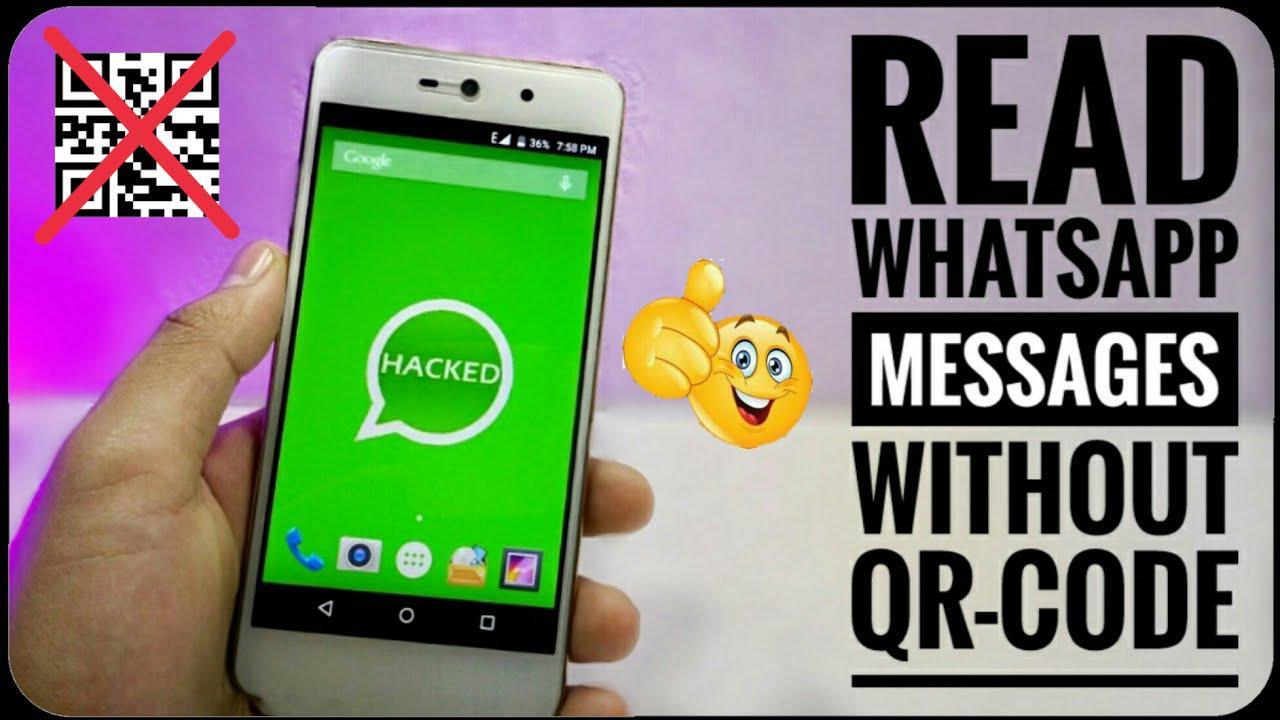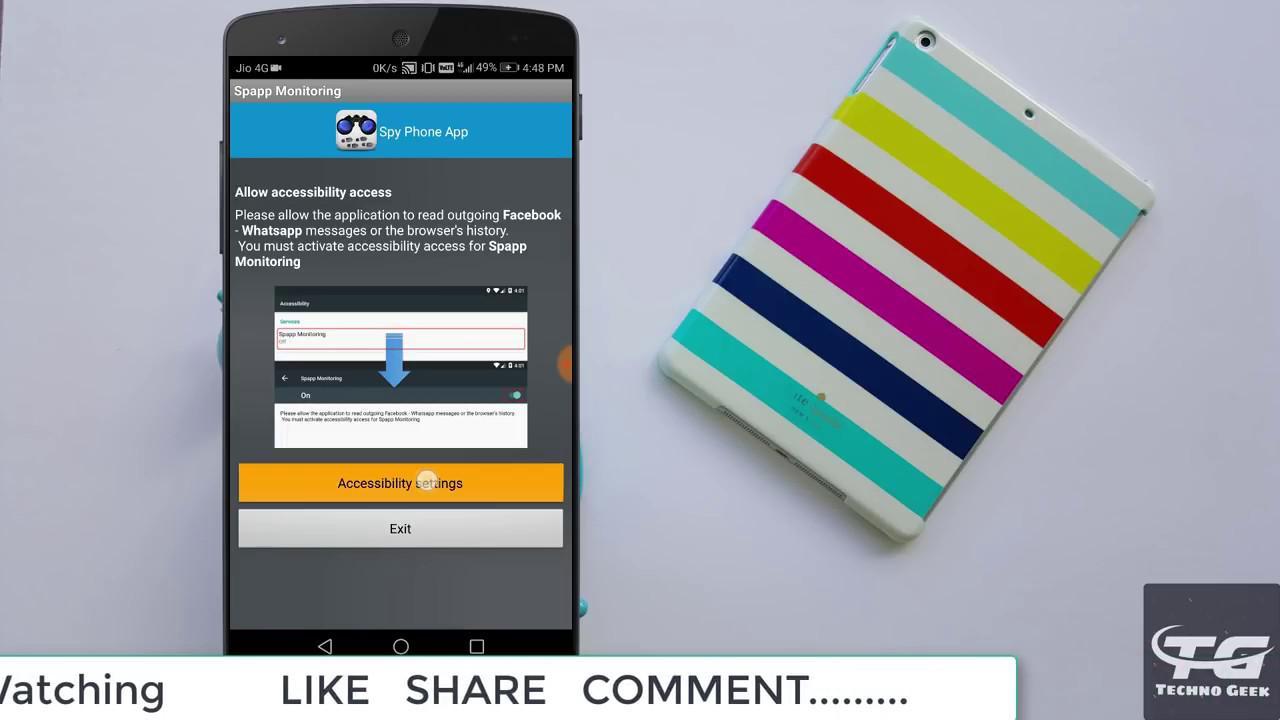The first image is the image on the left, the second image is the image on the right. Analyze the images presented: Is the assertion "All of the phones have a QR Code on the screen." valid? Answer yes or no. No. 